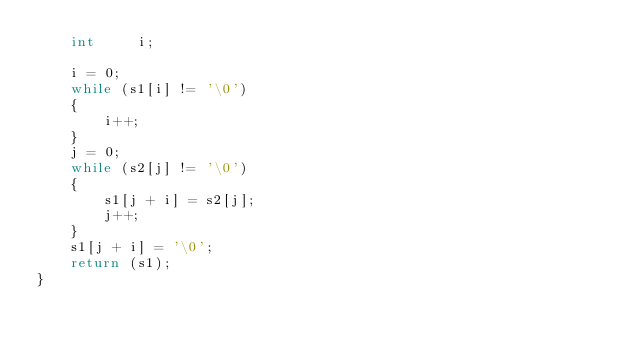<code> <loc_0><loc_0><loc_500><loc_500><_C_>	int		i;

	i = 0;
	while (s1[i] != '\0')
	{
		i++;
	}
	j = 0;
	while (s2[j] != '\0')
	{
		s1[j + i] = s2[j];
		j++;
	}
	s1[j + i] = '\0';
	return (s1);
}
</code> 